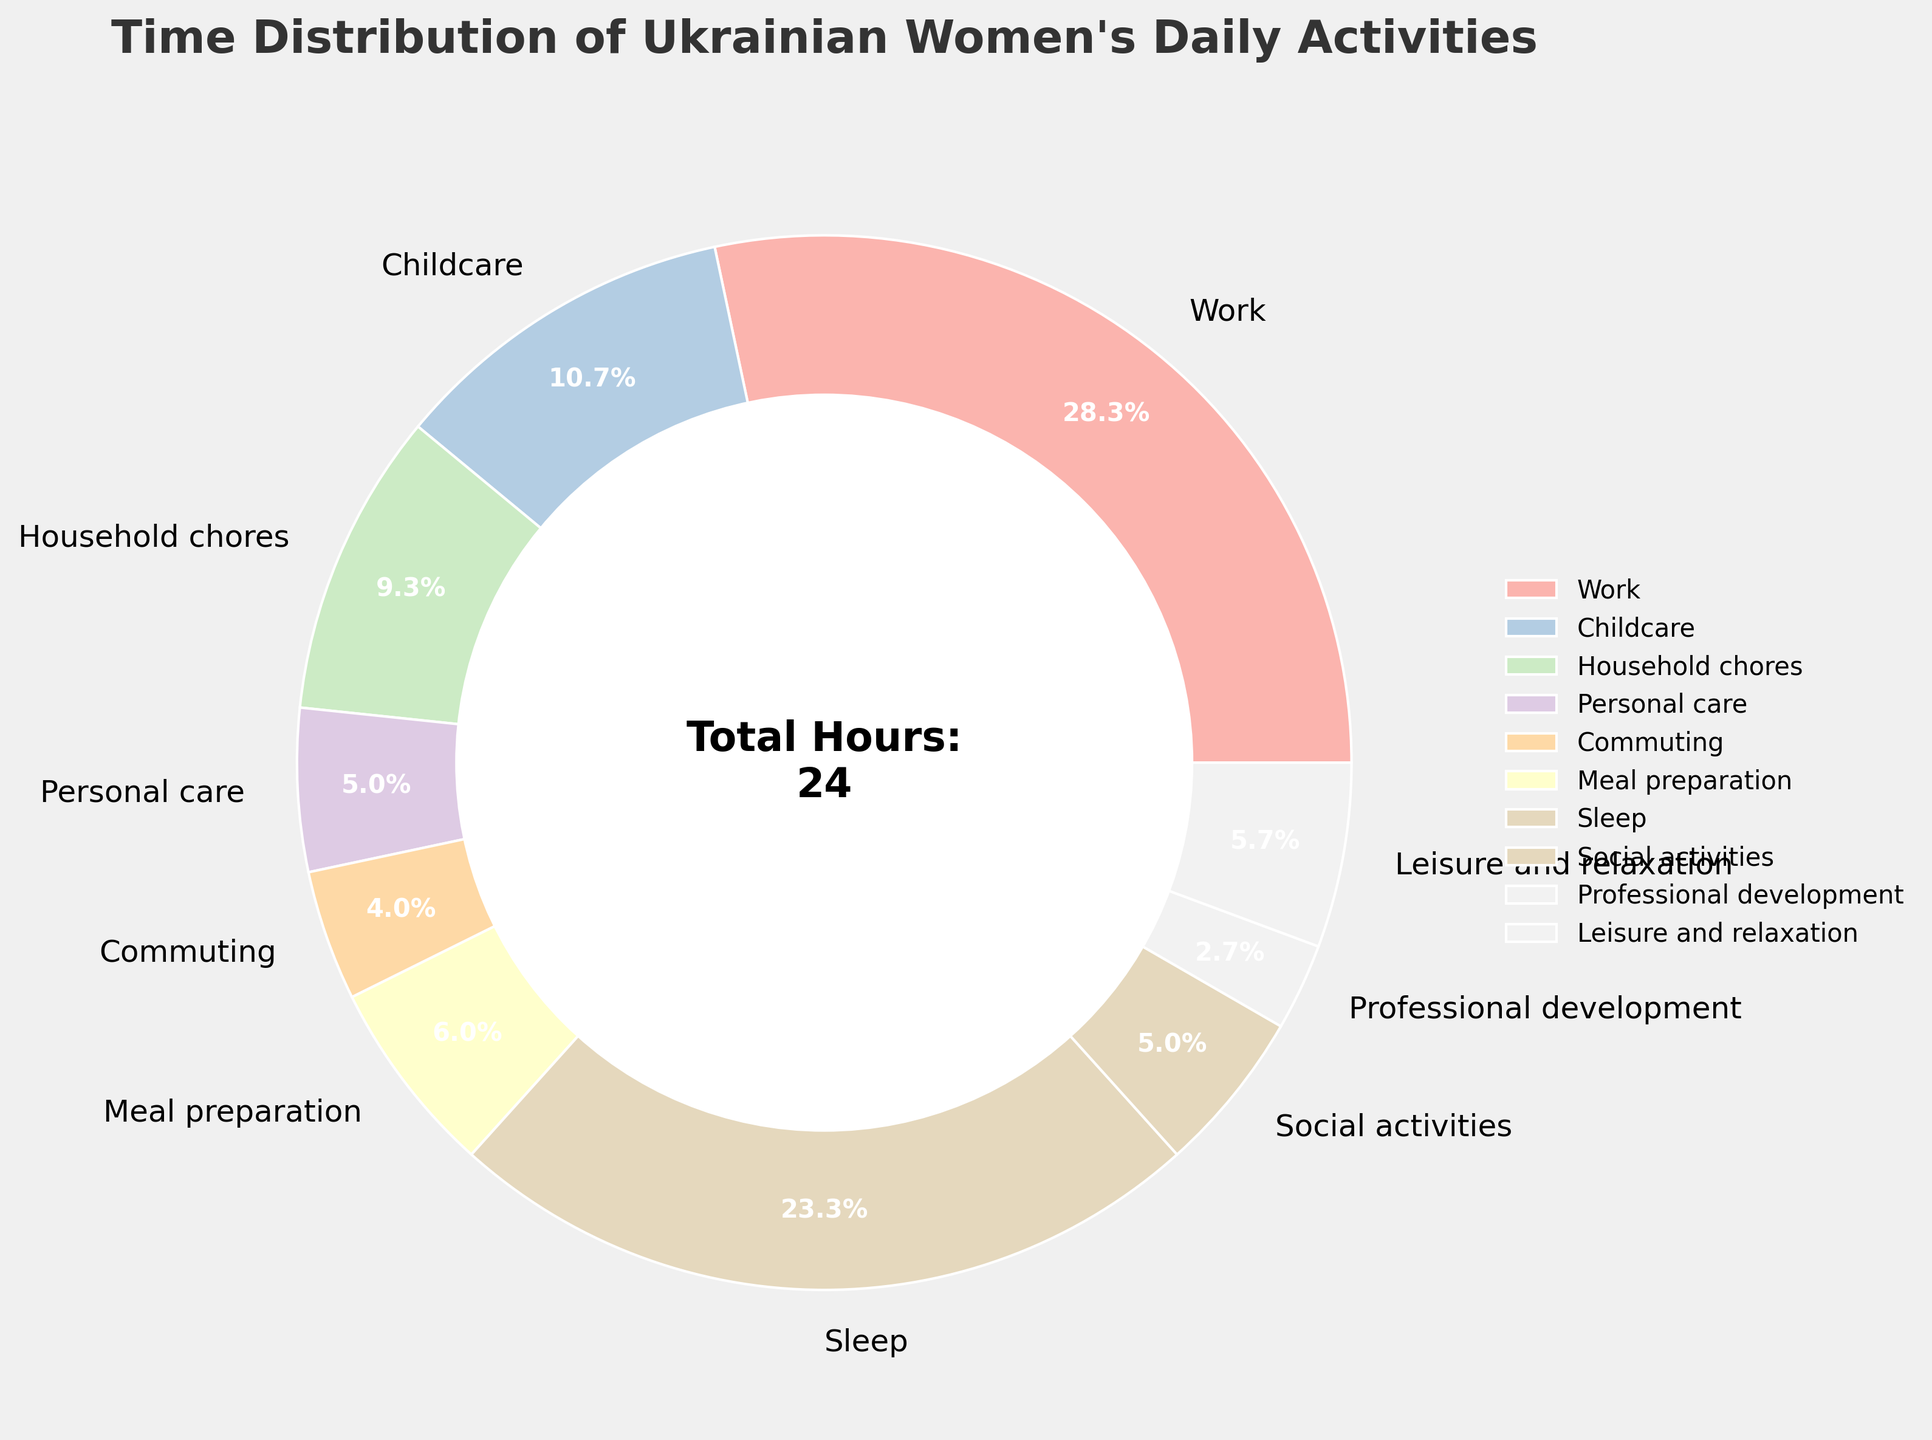what percentage of time is spent on professional development compared to work? Look at the pie chart and find that work takes 8.5 hours, and professional development takes 0.8 hours. Calculate the percentage: (0.8 / 8.5) * 100 ≈ 9.4%
Answer: 9.4% Which activity takes up most of the daily hours for Ukrainian women? Identify the segment of the pie chart with the largest value. Here, it is work with 8.5 hours.
Answer: Work Combine the hours spent on meal preparation and household chores. How much time is allocated to these activities? Find the hours for meal preparation (1.8) and household chores (2.8). Add them: 1.8 + 2.8 = 4.6 hours.
Answer: 4.6 hours Does sleep take up more or less time than work? Compare the hours allocated to sleep (7.0) and work (8.5). Sleep takes fewer hours than work.
Answer: Less Out of the time spent on social activities and leisure/relaxation, which activity has more hours? Compare social activities (1.5 hours) to leisure and relaxation (1.7 hours). Leisure and relaxation have more hours.
Answer: Leisure and relaxation What is the total percentage of time spent on childcare and household chores? Find the hours for childcare (3.2) and household chores (2.8). Sum them and calculate the percentage: (3.2 + 2.8) / 24 * 100 ≈ 25%.
Answer: 25% What do the colors in the pie chart represent? Examine the pie chart legend. Each color represents a different activity listed in the legend.
Answer: Different daily activities Is the time spent on commuting nearly the same as the time spent on personal care? If yes, how much less or more is it? Compare the hours of commuting (1.2) and personal care (1.5). Commuting is 0.3 hours less than personal care.
Answer: 0.3 hours less What takes up a smaller fraction of the day - social activities or professional development? Compare the pie chart segments. Social activities (1.5 hours) is larger than professional development (0.8 hours). Professional development takes up a smaller fraction.
Answer: Professional development If someone were to cut back their work hours by 2 hours and allocate it to leisure and relaxation, how many hours would they be left with for work and leisure respectively? Subtract 2 from work hours (8.5 - 2 = 6.5) and add these 2 hours to leisure (1.7 + 2 = 3.7).
Answer: Work: 6.5 hours, Leisure: 3.7 hours 